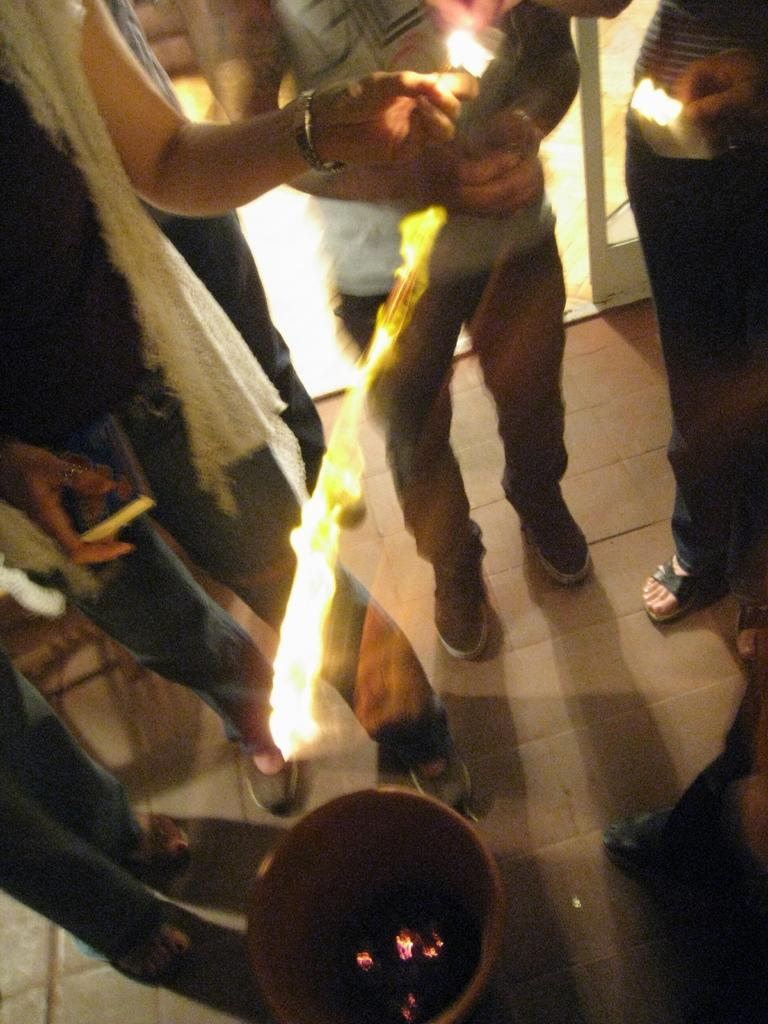What is happening in the image? There are people standing in the image, and there is a fire in the center of the image. What object is present at the bottom of the image? There is a pot at the bottom of the image. Can you see a tiger in the image? No, there is no tiger present in the image. Is there a drain visible in the image? No, there is no drain present in the image. 